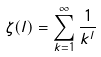<formula> <loc_0><loc_0><loc_500><loc_500>\zeta ( l ) = \sum _ { k = 1 } ^ { \infty } \frac { 1 } { k ^ { l } }</formula> 